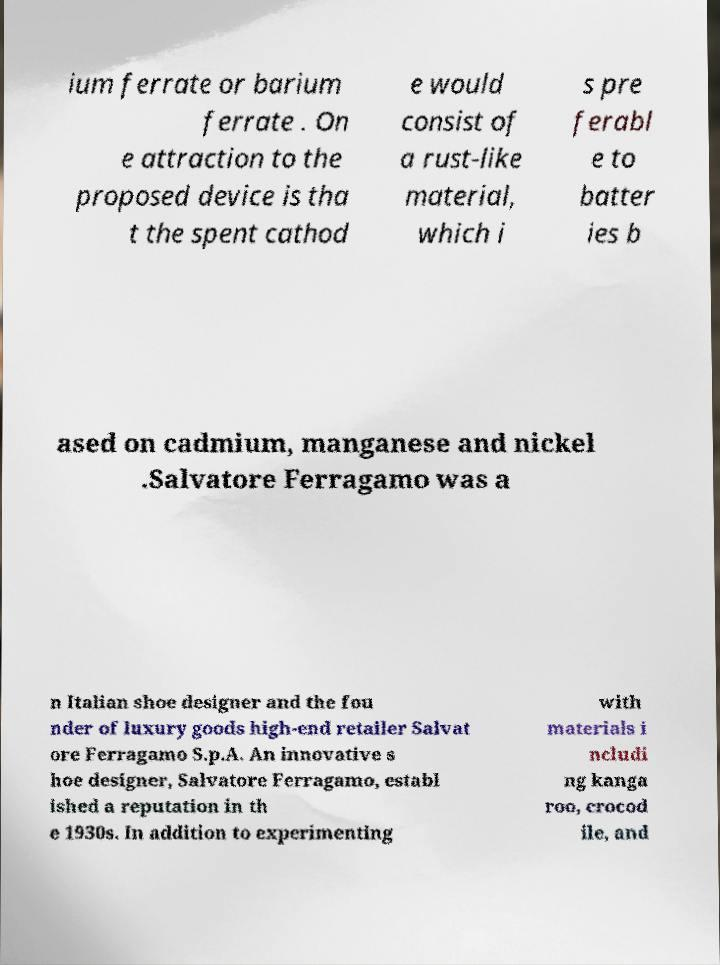There's text embedded in this image that I need extracted. Can you transcribe it verbatim? ium ferrate or barium ferrate . On e attraction to the proposed device is tha t the spent cathod e would consist of a rust-like material, which i s pre ferabl e to batter ies b ased on cadmium, manganese and nickel .Salvatore Ferragamo was a n Italian shoe designer and the fou nder of luxury goods high-end retailer Salvat ore Ferragamo S.p.A. An innovative s hoe designer, Salvatore Ferragamo, establ ished a reputation in th e 1930s. In addition to experimenting with materials i ncludi ng kanga roo, crocod ile, and 